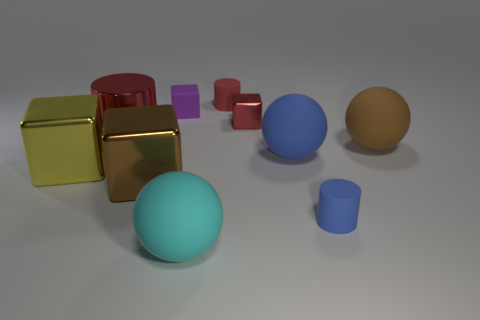Subtract all big blue balls. How many balls are left? 2 Subtract 1 spheres. How many spheres are left? 2 Subtract all cyan balls. How many balls are left? 2 Subtract all gray blocks. Subtract all cyan cylinders. How many blocks are left? 4 Subtract all gray spheres. How many green cylinders are left? 0 Subtract all small purple objects. Subtract all big rubber balls. How many objects are left? 6 Add 5 tiny red matte things. How many tiny red matte things are left? 6 Add 8 tiny yellow cylinders. How many tiny yellow cylinders exist? 8 Subtract 2 red cylinders. How many objects are left? 8 Subtract all balls. How many objects are left? 7 